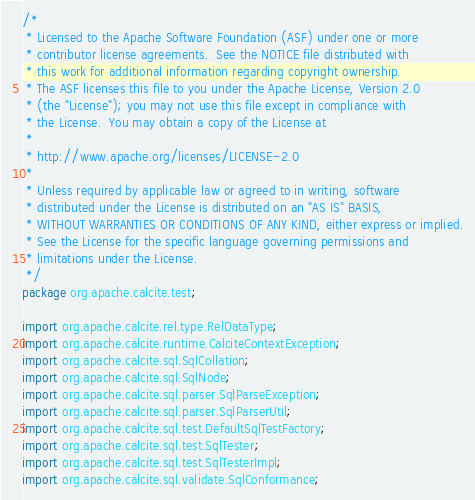<code> <loc_0><loc_0><loc_500><loc_500><_Java_>/*
 * Licensed to the Apache Software Foundation (ASF) under one or more
 * contributor license agreements.  See the NOTICE file distributed with
 * this work for additional information regarding copyright ownership.
 * The ASF licenses this file to you under the Apache License, Version 2.0
 * (the "License"); you may not use this file except in compliance with
 * the License.  You may obtain a copy of the License at
 *
 * http://www.apache.org/licenses/LICENSE-2.0
 *
 * Unless required by applicable law or agreed to in writing, software
 * distributed under the License is distributed on an "AS IS" BASIS,
 * WITHOUT WARRANTIES OR CONDITIONS OF ANY KIND, either express or implied.
 * See the License for the specific language governing permissions and
 * limitations under the License.
 */
package org.apache.calcite.test;

import org.apache.calcite.rel.type.RelDataType;
import org.apache.calcite.runtime.CalciteContextException;
import org.apache.calcite.sql.SqlCollation;
import org.apache.calcite.sql.SqlNode;
import org.apache.calcite.sql.parser.SqlParseException;
import org.apache.calcite.sql.parser.SqlParserUtil;
import org.apache.calcite.sql.test.DefaultSqlTestFactory;
import org.apache.calcite.sql.test.SqlTester;
import org.apache.calcite.sql.test.SqlTesterImpl;
import org.apache.calcite.sql.validate.SqlConformance;</code> 